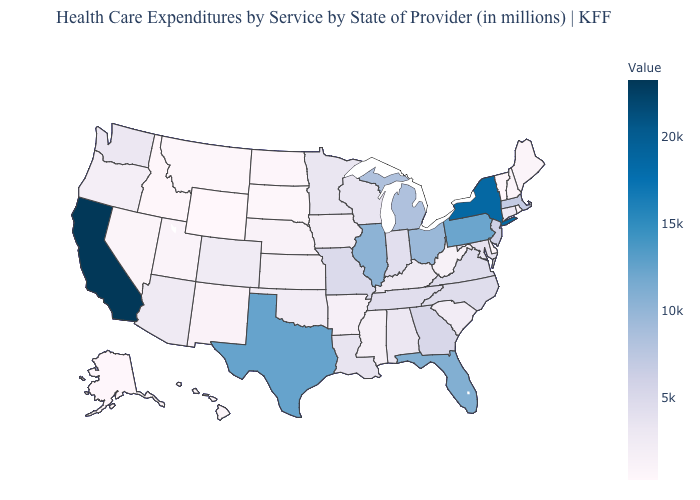Does Wyoming have the lowest value in the USA?
Concise answer only. Yes. Which states have the highest value in the USA?
Give a very brief answer. California. Which states have the lowest value in the USA?
Short answer required. Wyoming. Among the states that border Nebraska , does Wyoming have the lowest value?
Be succinct. Yes. Does Illinois have the highest value in the MidWest?
Write a very short answer. Yes. Is the legend a continuous bar?
Be succinct. Yes. Does Illinois have the highest value in the MidWest?
Quick response, please. Yes. Among the states that border Oregon , does Nevada have the highest value?
Quick response, please. No. 